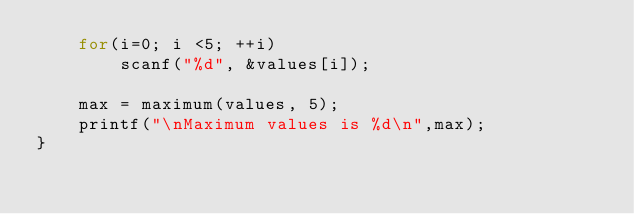<code> <loc_0><loc_0><loc_500><loc_500><_C_>    for(i=0; i <5; ++i)
        scanf("%d", &values[i]);

    max = maximum(values, 5);
    printf("\nMaximum values is %d\n",max);
}</code> 